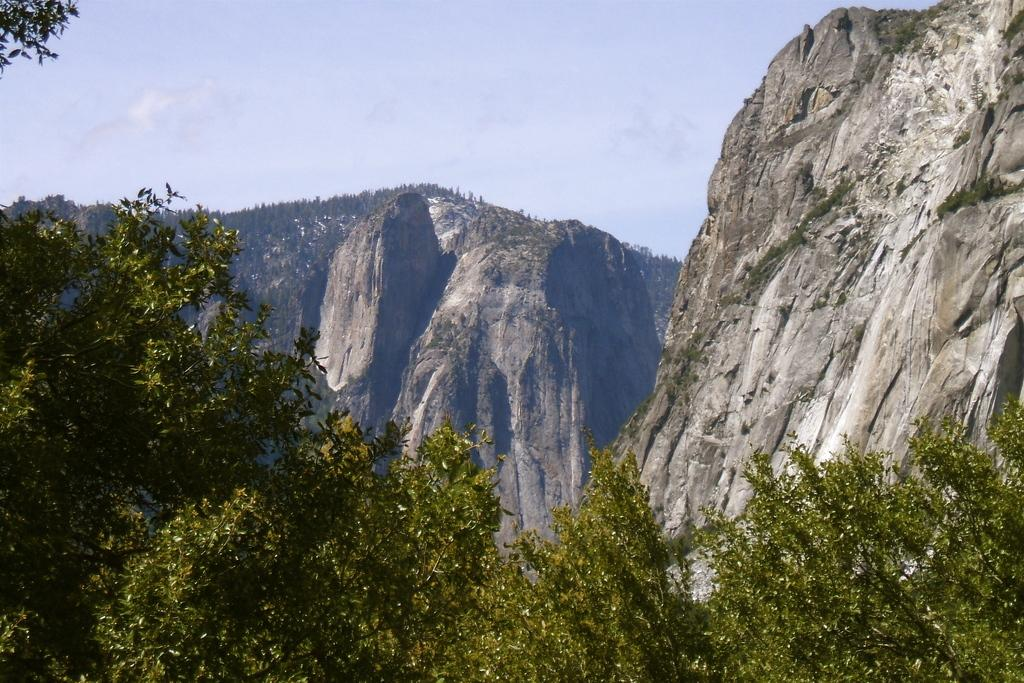What type of vegetation is in the foreground of the image? There are trees in the foreground of the image. What geological features can be seen in the middle of the image? There are mountains in the middle of the image. What is visible at the top of the image? The sky is visible at the top of the image. What position does the list hold in the image? There is no list present in the image. What process is depicted in the image? The image does not depict a process; it shows trees, mountains, and the sky. 